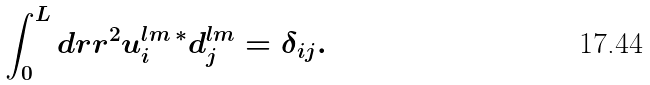Convert formula to latex. <formula><loc_0><loc_0><loc_500><loc_500>\int _ { 0 } ^ { L } d r r ^ { 2 } u ^ { l m \, \ast } _ { i } d ^ { l m } _ { j } = \delta _ { i j } .</formula> 